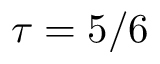<formula> <loc_0><loc_0><loc_500><loc_500>\tau = 5 / 6</formula> 